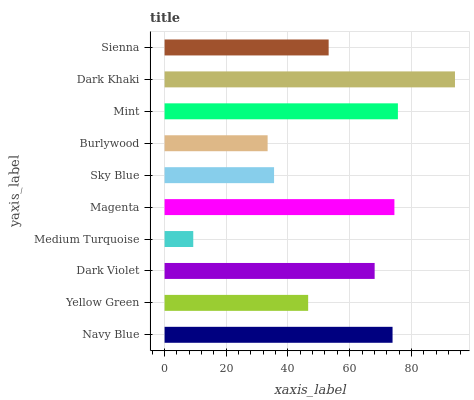Is Medium Turquoise the minimum?
Answer yes or no. Yes. Is Dark Khaki the maximum?
Answer yes or no. Yes. Is Yellow Green the minimum?
Answer yes or no. No. Is Yellow Green the maximum?
Answer yes or no. No. Is Navy Blue greater than Yellow Green?
Answer yes or no. Yes. Is Yellow Green less than Navy Blue?
Answer yes or no. Yes. Is Yellow Green greater than Navy Blue?
Answer yes or no. No. Is Navy Blue less than Yellow Green?
Answer yes or no. No. Is Dark Violet the high median?
Answer yes or no. Yes. Is Sienna the low median?
Answer yes or no. Yes. Is Yellow Green the high median?
Answer yes or no. No. Is Dark Violet the low median?
Answer yes or no. No. 